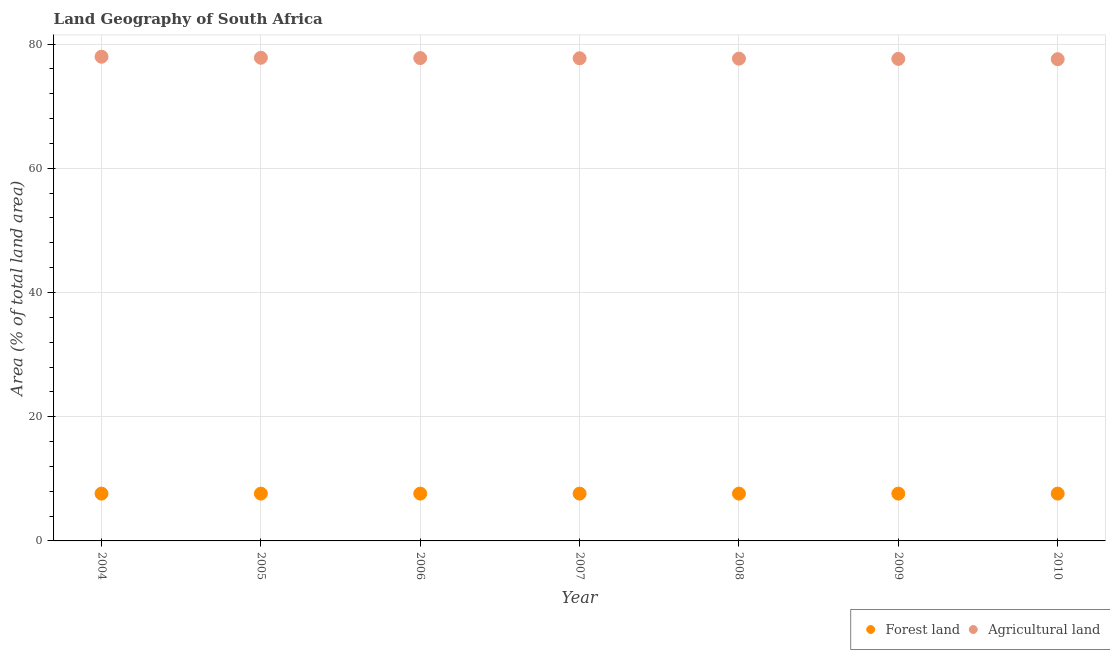Is the number of dotlines equal to the number of legend labels?
Your answer should be compact. Yes. What is the percentage of land area under agriculture in 2010?
Keep it short and to the point. 77.57. Across all years, what is the maximum percentage of land area under forests?
Offer a very short reply. 7.62. Across all years, what is the minimum percentage of land area under agriculture?
Offer a terse response. 77.57. What is the total percentage of land area under agriculture in the graph?
Make the answer very short. 544.1. What is the difference between the percentage of land area under agriculture in 2004 and that in 2006?
Offer a very short reply. 0.22. What is the difference between the percentage of land area under agriculture in 2007 and the percentage of land area under forests in 2009?
Give a very brief answer. 70.1. What is the average percentage of land area under forests per year?
Provide a short and direct response. 7.62. In the year 2010, what is the difference between the percentage of land area under agriculture and percentage of land area under forests?
Your answer should be compact. 69.95. In how many years, is the percentage of land area under forests greater than 36 %?
Offer a very short reply. 0. What is the ratio of the percentage of land area under agriculture in 2004 to that in 2007?
Offer a terse response. 1. Is the difference between the percentage of land area under forests in 2006 and 2008 greater than the difference between the percentage of land area under agriculture in 2006 and 2008?
Give a very brief answer. No. What is the difference between the highest and the second highest percentage of land area under agriculture?
Keep it short and to the point. 0.17. What is the difference between the highest and the lowest percentage of land area under forests?
Make the answer very short. 0. Is the sum of the percentage of land area under agriculture in 2004 and 2006 greater than the maximum percentage of land area under forests across all years?
Your response must be concise. Yes. Does the percentage of land area under agriculture monotonically increase over the years?
Your answer should be compact. No. How many dotlines are there?
Offer a very short reply. 2. How many years are there in the graph?
Your response must be concise. 7. Does the graph contain grids?
Offer a terse response. Yes. How many legend labels are there?
Provide a succinct answer. 2. How are the legend labels stacked?
Your response must be concise. Horizontal. What is the title of the graph?
Keep it short and to the point. Land Geography of South Africa. What is the label or title of the X-axis?
Offer a terse response. Year. What is the label or title of the Y-axis?
Ensure brevity in your answer.  Area (% of total land area). What is the Area (% of total land area) in Forest land in 2004?
Provide a succinct answer. 7.62. What is the Area (% of total land area) in Agricultural land in 2004?
Ensure brevity in your answer.  77.97. What is the Area (% of total land area) of Forest land in 2005?
Ensure brevity in your answer.  7.62. What is the Area (% of total land area) in Agricultural land in 2005?
Your answer should be very brief. 77.8. What is the Area (% of total land area) of Forest land in 2006?
Offer a terse response. 7.62. What is the Area (% of total land area) of Agricultural land in 2006?
Keep it short and to the point. 77.75. What is the Area (% of total land area) in Forest land in 2007?
Your answer should be very brief. 7.62. What is the Area (% of total land area) in Agricultural land in 2007?
Ensure brevity in your answer.  77.72. What is the Area (% of total land area) in Forest land in 2008?
Your response must be concise. 7.62. What is the Area (% of total land area) in Agricultural land in 2008?
Make the answer very short. 77.66. What is the Area (% of total land area) in Forest land in 2009?
Offer a very short reply. 7.62. What is the Area (% of total land area) of Agricultural land in 2009?
Make the answer very short. 77.62. What is the Area (% of total land area) of Forest land in 2010?
Your answer should be compact. 7.62. What is the Area (% of total land area) of Agricultural land in 2010?
Ensure brevity in your answer.  77.57. Across all years, what is the maximum Area (% of total land area) in Forest land?
Offer a very short reply. 7.62. Across all years, what is the maximum Area (% of total land area) in Agricultural land?
Provide a short and direct response. 77.97. Across all years, what is the minimum Area (% of total land area) of Forest land?
Ensure brevity in your answer.  7.62. Across all years, what is the minimum Area (% of total land area) of Agricultural land?
Offer a terse response. 77.57. What is the total Area (% of total land area) in Forest land in the graph?
Offer a very short reply. 53.32. What is the total Area (% of total land area) of Agricultural land in the graph?
Offer a terse response. 544.1. What is the difference between the Area (% of total land area) in Agricultural land in 2004 and that in 2005?
Offer a very short reply. 0.17. What is the difference between the Area (% of total land area) in Forest land in 2004 and that in 2006?
Your answer should be compact. 0. What is the difference between the Area (% of total land area) of Agricultural land in 2004 and that in 2006?
Provide a short and direct response. 0.22. What is the difference between the Area (% of total land area) of Forest land in 2004 and that in 2007?
Provide a succinct answer. 0. What is the difference between the Area (% of total land area) in Agricultural land in 2004 and that in 2007?
Ensure brevity in your answer.  0.25. What is the difference between the Area (% of total land area) of Forest land in 2004 and that in 2008?
Offer a very short reply. 0. What is the difference between the Area (% of total land area) of Agricultural land in 2004 and that in 2008?
Offer a terse response. 0.31. What is the difference between the Area (% of total land area) of Forest land in 2004 and that in 2009?
Provide a short and direct response. 0. What is the difference between the Area (% of total land area) in Agricultural land in 2004 and that in 2009?
Keep it short and to the point. 0.35. What is the difference between the Area (% of total land area) in Agricultural land in 2004 and that in 2010?
Your answer should be very brief. 0.4. What is the difference between the Area (% of total land area) in Forest land in 2005 and that in 2006?
Provide a short and direct response. 0. What is the difference between the Area (% of total land area) of Agricultural land in 2005 and that in 2006?
Offer a terse response. 0.05. What is the difference between the Area (% of total land area) of Forest land in 2005 and that in 2007?
Offer a very short reply. 0. What is the difference between the Area (% of total land area) in Agricultural land in 2005 and that in 2007?
Keep it short and to the point. 0.08. What is the difference between the Area (% of total land area) of Forest land in 2005 and that in 2008?
Offer a very short reply. 0. What is the difference between the Area (% of total land area) of Agricultural land in 2005 and that in 2008?
Ensure brevity in your answer.  0.14. What is the difference between the Area (% of total land area) in Agricultural land in 2005 and that in 2009?
Offer a very short reply. 0.18. What is the difference between the Area (% of total land area) of Forest land in 2005 and that in 2010?
Provide a short and direct response. 0. What is the difference between the Area (% of total land area) in Agricultural land in 2005 and that in 2010?
Your answer should be very brief. 0.23. What is the difference between the Area (% of total land area) of Forest land in 2006 and that in 2007?
Offer a terse response. 0. What is the difference between the Area (% of total land area) of Agricultural land in 2006 and that in 2007?
Your answer should be compact. 0.03. What is the difference between the Area (% of total land area) of Forest land in 2006 and that in 2008?
Your answer should be very brief. 0. What is the difference between the Area (% of total land area) in Agricultural land in 2006 and that in 2008?
Your answer should be compact. 0.09. What is the difference between the Area (% of total land area) of Agricultural land in 2006 and that in 2009?
Your answer should be very brief. 0.13. What is the difference between the Area (% of total land area) in Agricultural land in 2006 and that in 2010?
Give a very brief answer. 0.18. What is the difference between the Area (% of total land area) of Agricultural land in 2007 and that in 2008?
Offer a very short reply. 0.06. What is the difference between the Area (% of total land area) in Agricultural land in 2007 and that in 2009?
Offer a very short reply. 0.1. What is the difference between the Area (% of total land area) in Forest land in 2007 and that in 2010?
Your answer should be compact. 0. What is the difference between the Area (% of total land area) in Agricultural land in 2007 and that in 2010?
Ensure brevity in your answer.  0.15. What is the difference between the Area (% of total land area) of Forest land in 2008 and that in 2009?
Your response must be concise. 0. What is the difference between the Area (% of total land area) of Agricultural land in 2008 and that in 2009?
Provide a short and direct response. 0.04. What is the difference between the Area (% of total land area) of Forest land in 2008 and that in 2010?
Provide a succinct answer. 0. What is the difference between the Area (% of total land area) in Agricultural land in 2008 and that in 2010?
Provide a succinct answer. 0.09. What is the difference between the Area (% of total land area) in Forest land in 2009 and that in 2010?
Provide a short and direct response. 0. What is the difference between the Area (% of total land area) of Agricultural land in 2009 and that in 2010?
Keep it short and to the point. 0.05. What is the difference between the Area (% of total land area) of Forest land in 2004 and the Area (% of total land area) of Agricultural land in 2005?
Provide a short and direct response. -70.19. What is the difference between the Area (% of total land area) of Forest land in 2004 and the Area (% of total land area) of Agricultural land in 2006?
Your answer should be very brief. -70.13. What is the difference between the Area (% of total land area) of Forest land in 2004 and the Area (% of total land area) of Agricultural land in 2007?
Give a very brief answer. -70.1. What is the difference between the Area (% of total land area) in Forest land in 2004 and the Area (% of total land area) in Agricultural land in 2008?
Provide a succinct answer. -70.04. What is the difference between the Area (% of total land area) in Forest land in 2004 and the Area (% of total land area) in Agricultural land in 2009?
Provide a succinct answer. -70. What is the difference between the Area (% of total land area) of Forest land in 2004 and the Area (% of total land area) of Agricultural land in 2010?
Your response must be concise. -69.95. What is the difference between the Area (% of total land area) of Forest land in 2005 and the Area (% of total land area) of Agricultural land in 2006?
Your response must be concise. -70.13. What is the difference between the Area (% of total land area) in Forest land in 2005 and the Area (% of total land area) in Agricultural land in 2007?
Keep it short and to the point. -70.1. What is the difference between the Area (% of total land area) of Forest land in 2005 and the Area (% of total land area) of Agricultural land in 2008?
Make the answer very short. -70.04. What is the difference between the Area (% of total land area) of Forest land in 2005 and the Area (% of total land area) of Agricultural land in 2009?
Keep it short and to the point. -70. What is the difference between the Area (% of total land area) in Forest land in 2005 and the Area (% of total land area) in Agricultural land in 2010?
Ensure brevity in your answer.  -69.95. What is the difference between the Area (% of total land area) of Forest land in 2006 and the Area (% of total land area) of Agricultural land in 2007?
Offer a terse response. -70.1. What is the difference between the Area (% of total land area) in Forest land in 2006 and the Area (% of total land area) in Agricultural land in 2008?
Your response must be concise. -70.04. What is the difference between the Area (% of total land area) of Forest land in 2006 and the Area (% of total land area) of Agricultural land in 2009?
Provide a short and direct response. -70. What is the difference between the Area (% of total land area) in Forest land in 2006 and the Area (% of total land area) in Agricultural land in 2010?
Keep it short and to the point. -69.95. What is the difference between the Area (% of total land area) in Forest land in 2007 and the Area (% of total land area) in Agricultural land in 2008?
Your answer should be very brief. -70.04. What is the difference between the Area (% of total land area) of Forest land in 2007 and the Area (% of total land area) of Agricultural land in 2009?
Keep it short and to the point. -70. What is the difference between the Area (% of total land area) in Forest land in 2007 and the Area (% of total land area) in Agricultural land in 2010?
Offer a very short reply. -69.95. What is the difference between the Area (% of total land area) of Forest land in 2008 and the Area (% of total land area) of Agricultural land in 2009?
Provide a short and direct response. -70. What is the difference between the Area (% of total land area) in Forest land in 2008 and the Area (% of total land area) in Agricultural land in 2010?
Provide a short and direct response. -69.95. What is the difference between the Area (% of total land area) in Forest land in 2009 and the Area (% of total land area) in Agricultural land in 2010?
Give a very brief answer. -69.95. What is the average Area (% of total land area) of Forest land per year?
Ensure brevity in your answer.  7.62. What is the average Area (% of total land area) of Agricultural land per year?
Offer a terse response. 77.73. In the year 2004, what is the difference between the Area (% of total land area) of Forest land and Area (% of total land area) of Agricultural land?
Your answer should be very brief. -70.35. In the year 2005, what is the difference between the Area (% of total land area) in Forest land and Area (% of total land area) in Agricultural land?
Ensure brevity in your answer.  -70.19. In the year 2006, what is the difference between the Area (% of total land area) of Forest land and Area (% of total land area) of Agricultural land?
Your answer should be very brief. -70.13. In the year 2007, what is the difference between the Area (% of total land area) in Forest land and Area (% of total land area) in Agricultural land?
Ensure brevity in your answer.  -70.1. In the year 2008, what is the difference between the Area (% of total land area) of Forest land and Area (% of total land area) of Agricultural land?
Your answer should be compact. -70.04. In the year 2009, what is the difference between the Area (% of total land area) in Forest land and Area (% of total land area) in Agricultural land?
Make the answer very short. -70. In the year 2010, what is the difference between the Area (% of total land area) in Forest land and Area (% of total land area) in Agricultural land?
Your answer should be compact. -69.95. What is the ratio of the Area (% of total land area) in Forest land in 2004 to that in 2005?
Provide a succinct answer. 1. What is the ratio of the Area (% of total land area) of Forest land in 2004 to that in 2006?
Ensure brevity in your answer.  1. What is the ratio of the Area (% of total land area) in Agricultural land in 2004 to that in 2006?
Keep it short and to the point. 1. What is the ratio of the Area (% of total land area) of Forest land in 2004 to that in 2008?
Your answer should be very brief. 1. What is the ratio of the Area (% of total land area) of Forest land in 2004 to that in 2009?
Your response must be concise. 1. What is the ratio of the Area (% of total land area) in Agricultural land in 2004 to that in 2009?
Your answer should be very brief. 1. What is the ratio of the Area (% of total land area) in Agricultural land in 2004 to that in 2010?
Offer a terse response. 1.01. What is the ratio of the Area (% of total land area) of Forest land in 2005 to that in 2006?
Give a very brief answer. 1. What is the ratio of the Area (% of total land area) of Forest land in 2005 to that in 2007?
Ensure brevity in your answer.  1. What is the ratio of the Area (% of total land area) of Forest land in 2005 to that in 2008?
Your response must be concise. 1. What is the ratio of the Area (% of total land area) in Agricultural land in 2005 to that in 2008?
Your answer should be compact. 1. What is the ratio of the Area (% of total land area) of Forest land in 2005 to that in 2009?
Offer a very short reply. 1. What is the ratio of the Area (% of total land area) in Forest land in 2005 to that in 2010?
Your answer should be compact. 1. What is the ratio of the Area (% of total land area) of Forest land in 2006 to that in 2007?
Your answer should be very brief. 1. What is the ratio of the Area (% of total land area) in Agricultural land in 2006 to that in 2007?
Make the answer very short. 1. What is the ratio of the Area (% of total land area) of Agricultural land in 2006 to that in 2008?
Ensure brevity in your answer.  1. What is the ratio of the Area (% of total land area) of Forest land in 2006 to that in 2009?
Keep it short and to the point. 1. What is the ratio of the Area (% of total land area) in Forest land in 2006 to that in 2010?
Give a very brief answer. 1. What is the ratio of the Area (% of total land area) of Agricultural land in 2006 to that in 2010?
Offer a terse response. 1. What is the ratio of the Area (% of total land area) in Forest land in 2007 to that in 2008?
Your answer should be very brief. 1. What is the ratio of the Area (% of total land area) in Agricultural land in 2007 to that in 2008?
Ensure brevity in your answer.  1. What is the ratio of the Area (% of total land area) in Forest land in 2007 to that in 2010?
Ensure brevity in your answer.  1. What is the ratio of the Area (% of total land area) in Agricultural land in 2007 to that in 2010?
Give a very brief answer. 1. What is the ratio of the Area (% of total land area) of Forest land in 2008 to that in 2009?
Offer a very short reply. 1. What is the ratio of the Area (% of total land area) of Forest land in 2008 to that in 2010?
Ensure brevity in your answer.  1. What is the difference between the highest and the second highest Area (% of total land area) of Forest land?
Make the answer very short. 0. What is the difference between the highest and the second highest Area (% of total land area) in Agricultural land?
Make the answer very short. 0.17. What is the difference between the highest and the lowest Area (% of total land area) in Agricultural land?
Give a very brief answer. 0.4. 